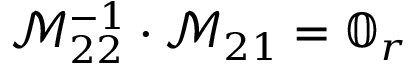Convert formula to latex. <formula><loc_0><loc_0><loc_500><loc_500>\mathcal { M } _ { 2 2 } ^ { - 1 } \cdot \mathcal { M } _ { 2 1 } = \mathbb { 0 } _ { r }</formula> 